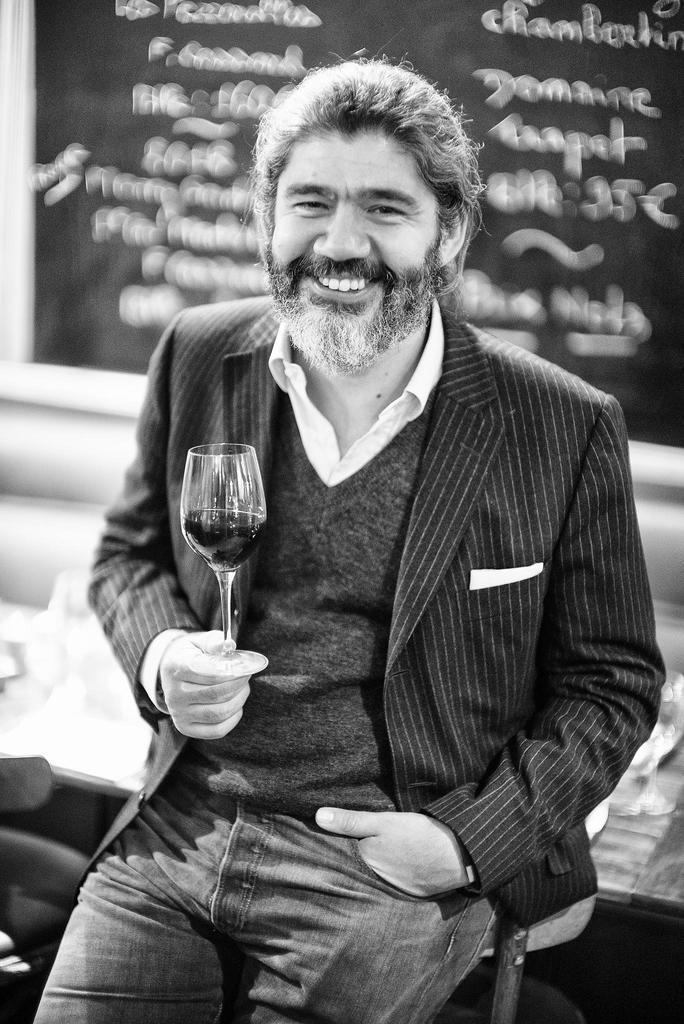How would you summarize this image in a sentence or two? A man is leaning into a bench with a wine glass in his right hand. 